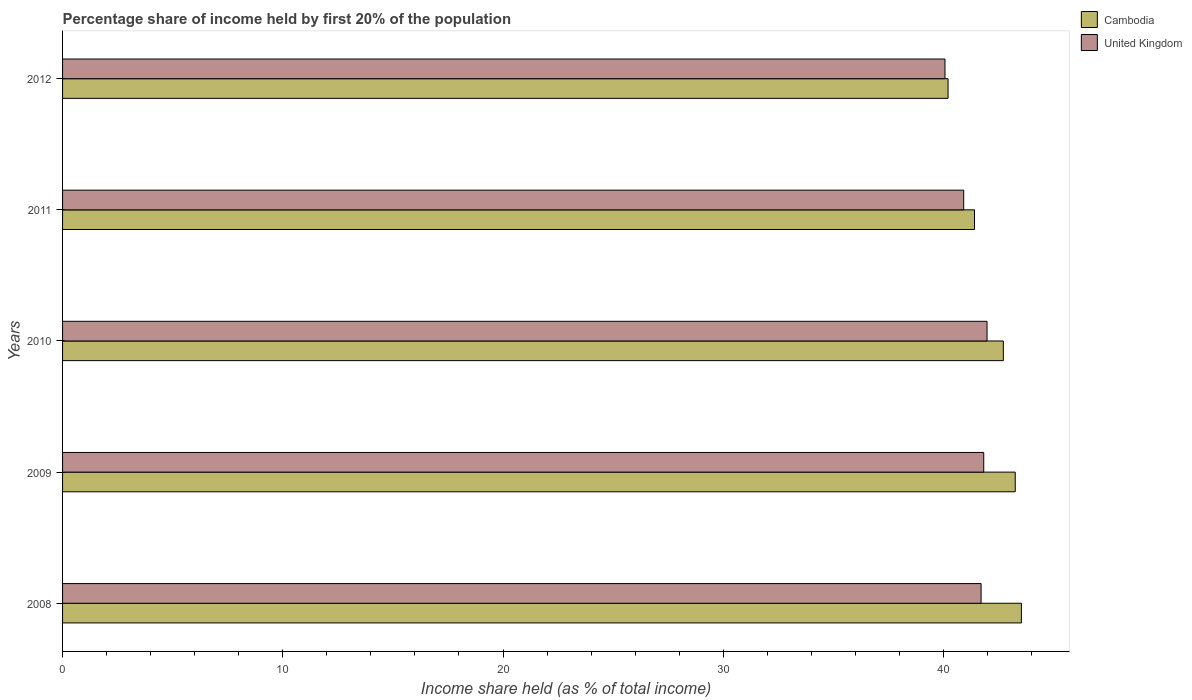How many different coloured bars are there?
Make the answer very short. 2. In how many cases, is the number of bars for a given year not equal to the number of legend labels?
Your answer should be very brief. 0. What is the share of income held by first 20% of the population in United Kingdom in 2009?
Give a very brief answer. 41.83. Across all years, what is the maximum share of income held by first 20% of the population in United Kingdom?
Your answer should be compact. 41.98. Across all years, what is the minimum share of income held by first 20% of the population in United Kingdom?
Provide a short and direct response. 40.07. In which year was the share of income held by first 20% of the population in Cambodia maximum?
Your answer should be very brief. 2008. What is the total share of income held by first 20% of the population in United Kingdom in the graph?
Your answer should be very brief. 206.51. What is the difference between the share of income held by first 20% of the population in Cambodia in 2008 and that in 2010?
Make the answer very short. 0.82. What is the difference between the share of income held by first 20% of the population in United Kingdom in 2010 and the share of income held by first 20% of the population in Cambodia in 2011?
Your response must be concise. 0.57. What is the average share of income held by first 20% of the population in United Kingdom per year?
Make the answer very short. 41.3. In the year 2012, what is the difference between the share of income held by first 20% of the population in United Kingdom and share of income held by first 20% of the population in Cambodia?
Keep it short and to the point. -0.14. In how many years, is the share of income held by first 20% of the population in United Kingdom greater than 34 %?
Your response must be concise. 5. What is the ratio of the share of income held by first 20% of the population in United Kingdom in 2009 to that in 2010?
Your response must be concise. 1. Is the share of income held by first 20% of the population in Cambodia in 2009 less than that in 2010?
Your answer should be compact. No. Is the difference between the share of income held by first 20% of the population in United Kingdom in 2010 and 2012 greater than the difference between the share of income held by first 20% of the population in Cambodia in 2010 and 2012?
Offer a very short reply. No. What is the difference between the highest and the second highest share of income held by first 20% of the population in Cambodia?
Your response must be concise. 0.28. What is the difference between the highest and the lowest share of income held by first 20% of the population in United Kingdom?
Give a very brief answer. 1.91. In how many years, is the share of income held by first 20% of the population in Cambodia greater than the average share of income held by first 20% of the population in Cambodia taken over all years?
Provide a succinct answer. 3. Is the sum of the share of income held by first 20% of the population in United Kingdom in 2008 and 2010 greater than the maximum share of income held by first 20% of the population in Cambodia across all years?
Provide a short and direct response. Yes. What does the 1st bar from the top in 2010 represents?
Provide a short and direct response. United Kingdom. What does the 1st bar from the bottom in 2010 represents?
Your response must be concise. Cambodia. How many bars are there?
Provide a succinct answer. 10. What is the difference between two consecutive major ticks on the X-axis?
Ensure brevity in your answer.  10. Does the graph contain grids?
Give a very brief answer. No. Where does the legend appear in the graph?
Provide a succinct answer. Top right. How are the legend labels stacked?
Provide a short and direct response. Vertical. What is the title of the graph?
Your answer should be compact. Percentage share of income held by first 20% of the population. What is the label or title of the X-axis?
Provide a succinct answer. Income share held (as % of total income). What is the label or title of the Y-axis?
Offer a very short reply. Years. What is the Income share held (as % of total income) in Cambodia in 2008?
Provide a short and direct response. 43.54. What is the Income share held (as % of total income) of United Kingdom in 2008?
Ensure brevity in your answer.  41.71. What is the Income share held (as % of total income) in Cambodia in 2009?
Ensure brevity in your answer.  43.26. What is the Income share held (as % of total income) in United Kingdom in 2009?
Provide a short and direct response. 41.83. What is the Income share held (as % of total income) of Cambodia in 2010?
Offer a very short reply. 42.72. What is the Income share held (as % of total income) of United Kingdom in 2010?
Your answer should be compact. 41.98. What is the Income share held (as % of total income) in Cambodia in 2011?
Provide a succinct answer. 41.41. What is the Income share held (as % of total income) in United Kingdom in 2011?
Your answer should be compact. 40.92. What is the Income share held (as % of total income) in Cambodia in 2012?
Offer a very short reply. 40.21. What is the Income share held (as % of total income) in United Kingdom in 2012?
Provide a succinct answer. 40.07. Across all years, what is the maximum Income share held (as % of total income) in Cambodia?
Give a very brief answer. 43.54. Across all years, what is the maximum Income share held (as % of total income) in United Kingdom?
Offer a very short reply. 41.98. Across all years, what is the minimum Income share held (as % of total income) in Cambodia?
Provide a succinct answer. 40.21. Across all years, what is the minimum Income share held (as % of total income) of United Kingdom?
Make the answer very short. 40.07. What is the total Income share held (as % of total income) in Cambodia in the graph?
Offer a terse response. 211.14. What is the total Income share held (as % of total income) of United Kingdom in the graph?
Your answer should be compact. 206.51. What is the difference between the Income share held (as % of total income) in Cambodia in 2008 and that in 2009?
Your answer should be compact. 0.28. What is the difference between the Income share held (as % of total income) of United Kingdom in 2008 and that in 2009?
Provide a short and direct response. -0.12. What is the difference between the Income share held (as % of total income) of Cambodia in 2008 and that in 2010?
Your answer should be very brief. 0.82. What is the difference between the Income share held (as % of total income) in United Kingdom in 2008 and that in 2010?
Provide a succinct answer. -0.27. What is the difference between the Income share held (as % of total income) of Cambodia in 2008 and that in 2011?
Make the answer very short. 2.13. What is the difference between the Income share held (as % of total income) of United Kingdom in 2008 and that in 2011?
Offer a terse response. 0.79. What is the difference between the Income share held (as % of total income) in Cambodia in 2008 and that in 2012?
Provide a succinct answer. 3.33. What is the difference between the Income share held (as % of total income) of United Kingdom in 2008 and that in 2012?
Your response must be concise. 1.64. What is the difference between the Income share held (as % of total income) of Cambodia in 2009 and that in 2010?
Your answer should be very brief. 0.54. What is the difference between the Income share held (as % of total income) of United Kingdom in 2009 and that in 2010?
Offer a terse response. -0.15. What is the difference between the Income share held (as % of total income) in Cambodia in 2009 and that in 2011?
Make the answer very short. 1.85. What is the difference between the Income share held (as % of total income) of United Kingdom in 2009 and that in 2011?
Offer a very short reply. 0.91. What is the difference between the Income share held (as % of total income) of Cambodia in 2009 and that in 2012?
Your answer should be compact. 3.05. What is the difference between the Income share held (as % of total income) of United Kingdom in 2009 and that in 2012?
Your response must be concise. 1.76. What is the difference between the Income share held (as % of total income) in Cambodia in 2010 and that in 2011?
Your answer should be very brief. 1.31. What is the difference between the Income share held (as % of total income) of United Kingdom in 2010 and that in 2011?
Provide a succinct answer. 1.06. What is the difference between the Income share held (as % of total income) of Cambodia in 2010 and that in 2012?
Make the answer very short. 2.51. What is the difference between the Income share held (as % of total income) of United Kingdom in 2010 and that in 2012?
Ensure brevity in your answer.  1.91. What is the difference between the Income share held (as % of total income) in United Kingdom in 2011 and that in 2012?
Offer a terse response. 0.85. What is the difference between the Income share held (as % of total income) of Cambodia in 2008 and the Income share held (as % of total income) of United Kingdom in 2009?
Make the answer very short. 1.71. What is the difference between the Income share held (as % of total income) in Cambodia in 2008 and the Income share held (as % of total income) in United Kingdom in 2010?
Provide a succinct answer. 1.56. What is the difference between the Income share held (as % of total income) of Cambodia in 2008 and the Income share held (as % of total income) of United Kingdom in 2011?
Provide a short and direct response. 2.62. What is the difference between the Income share held (as % of total income) in Cambodia in 2008 and the Income share held (as % of total income) in United Kingdom in 2012?
Give a very brief answer. 3.47. What is the difference between the Income share held (as % of total income) in Cambodia in 2009 and the Income share held (as % of total income) in United Kingdom in 2010?
Your answer should be very brief. 1.28. What is the difference between the Income share held (as % of total income) in Cambodia in 2009 and the Income share held (as % of total income) in United Kingdom in 2011?
Make the answer very short. 2.34. What is the difference between the Income share held (as % of total income) in Cambodia in 2009 and the Income share held (as % of total income) in United Kingdom in 2012?
Ensure brevity in your answer.  3.19. What is the difference between the Income share held (as % of total income) in Cambodia in 2010 and the Income share held (as % of total income) in United Kingdom in 2011?
Provide a short and direct response. 1.8. What is the difference between the Income share held (as % of total income) of Cambodia in 2010 and the Income share held (as % of total income) of United Kingdom in 2012?
Provide a short and direct response. 2.65. What is the difference between the Income share held (as % of total income) of Cambodia in 2011 and the Income share held (as % of total income) of United Kingdom in 2012?
Your answer should be compact. 1.34. What is the average Income share held (as % of total income) of Cambodia per year?
Your answer should be very brief. 42.23. What is the average Income share held (as % of total income) in United Kingdom per year?
Your response must be concise. 41.3. In the year 2008, what is the difference between the Income share held (as % of total income) of Cambodia and Income share held (as % of total income) of United Kingdom?
Your answer should be compact. 1.83. In the year 2009, what is the difference between the Income share held (as % of total income) of Cambodia and Income share held (as % of total income) of United Kingdom?
Your answer should be very brief. 1.43. In the year 2010, what is the difference between the Income share held (as % of total income) in Cambodia and Income share held (as % of total income) in United Kingdom?
Offer a terse response. 0.74. In the year 2011, what is the difference between the Income share held (as % of total income) in Cambodia and Income share held (as % of total income) in United Kingdom?
Offer a very short reply. 0.49. In the year 2012, what is the difference between the Income share held (as % of total income) in Cambodia and Income share held (as % of total income) in United Kingdom?
Offer a terse response. 0.14. What is the ratio of the Income share held (as % of total income) in Cambodia in 2008 to that in 2009?
Provide a short and direct response. 1.01. What is the ratio of the Income share held (as % of total income) in United Kingdom in 2008 to that in 2009?
Offer a very short reply. 1. What is the ratio of the Income share held (as % of total income) in Cambodia in 2008 to that in 2010?
Offer a terse response. 1.02. What is the ratio of the Income share held (as % of total income) in United Kingdom in 2008 to that in 2010?
Ensure brevity in your answer.  0.99. What is the ratio of the Income share held (as % of total income) of Cambodia in 2008 to that in 2011?
Provide a succinct answer. 1.05. What is the ratio of the Income share held (as % of total income) of United Kingdom in 2008 to that in 2011?
Ensure brevity in your answer.  1.02. What is the ratio of the Income share held (as % of total income) in Cambodia in 2008 to that in 2012?
Give a very brief answer. 1.08. What is the ratio of the Income share held (as % of total income) of United Kingdom in 2008 to that in 2012?
Keep it short and to the point. 1.04. What is the ratio of the Income share held (as % of total income) in Cambodia in 2009 to that in 2010?
Ensure brevity in your answer.  1.01. What is the ratio of the Income share held (as % of total income) of United Kingdom in 2009 to that in 2010?
Keep it short and to the point. 1. What is the ratio of the Income share held (as % of total income) in Cambodia in 2009 to that in 2011?
Provide a succinct answer. 1.04. What is the ratio of the Income share held (as % of total income) of United Kingdom in 2009 to that in 2011?
Your response must be concise. 1.02. What is the ratio of the Income share held (as % of total income) of Cambodia in 2009 to that in 2012?
Ensure brevity in your answer.  1.08. What is the ratio of the Income share held (as % of total income) of United Kingdom in 2009 to that in 2012?
Give a very brief answer. 1.04. What is the ratio of the Income share held (as % of total income) of Cambodia in 2010 to that in 2011?
Your answer should be very brief. 1.03. What is the ratio of the Income share held (as % of total income) in United Kingdom in 2010 to that in 2011?
Offer a terse response. 1.03. What is the ratio of the Income share held (as % of total income) in Cambodia in 2010 to that in 2012?
Offer a terse response. 1.06. What is the ratio of the Income share held (as % of total income) of United Kingdom in 2010 to that in 2012?
Offer a very short reply. 1.05. What is the ratio of the Income share held (as % of total income) of Cambodia in 2011 to that in 2012?
Your answer should be very brief. 1.03. What is the ratio of the Income share held (as % of total income) in United Kingdom in 2011 to that in 2012?
Make the answer very short. 1.02. What is the difference between the highest and the second highest Income share held (as % of total income) in Cambodia?
Offer a very short reply. 0.28. What is the difference between the highest and the second highest Income share held (as % of total income) in United Kingdom?
Your answer should be compact. 0.15. What is the difference between the highest and the lowest Income share held (as % of total income) in Cambodia?
Give a very brief answer. 3.33. What is the difference between the highest and the lowest Income share held (as % of total income) in United Kingdom?
Your answer should be compact. 1.91. 